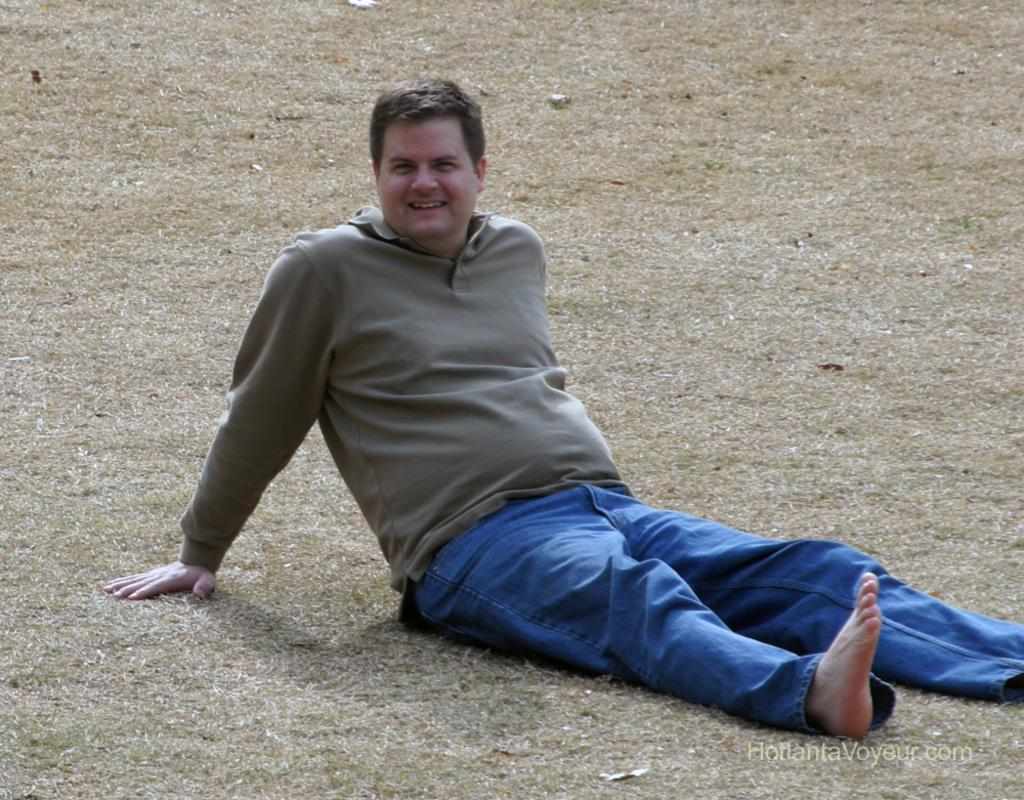Who is present in the image? There is a man in the image. What is the man doing in the image? The man is smiling in the image. Where is the man sitting in the image? The man is sitting on the grass in the image. What type of tank can be seen in the background of the image? There is no tank present in the image. How many cherries is the man holding in the image? There are no cherries visible in the image. 